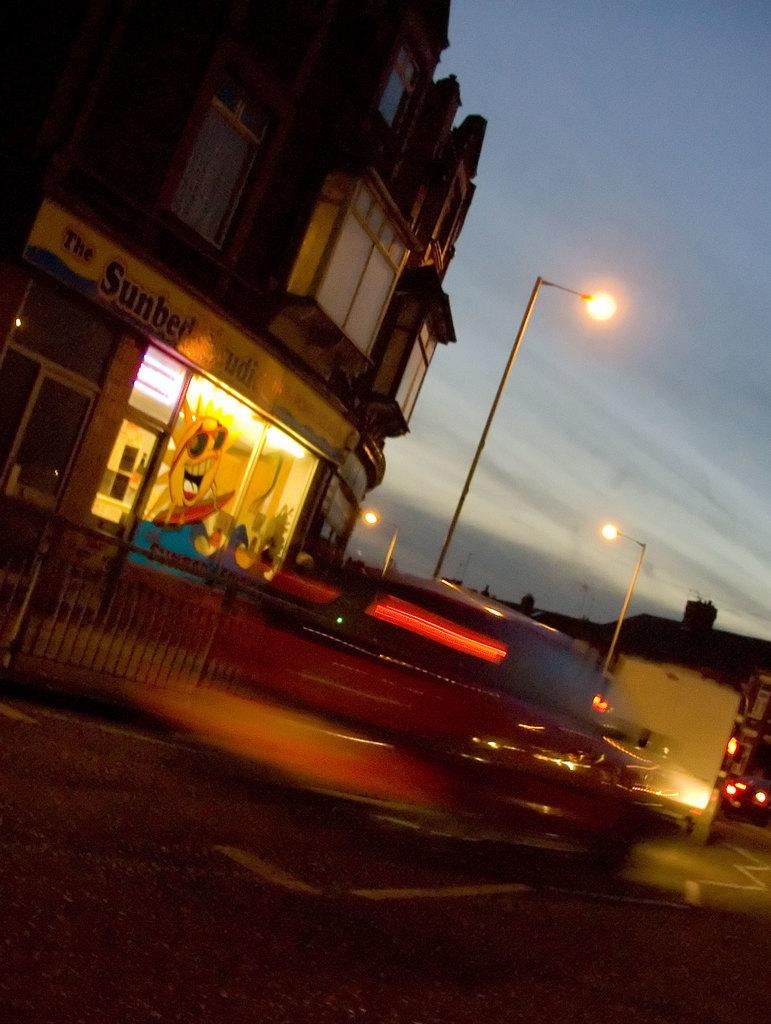What type of structure is visible in the image? There is a building in the image. What type of lighting is present in the image? There are pole lights in the image. What is happening on the road in the image? There are vehicles moving on the road in the image. How would you describe the sky in the image? The sky is cloudy in the image. How many balls are bouncing on the cushion in the image? There are no balls or cushions present in the image. 